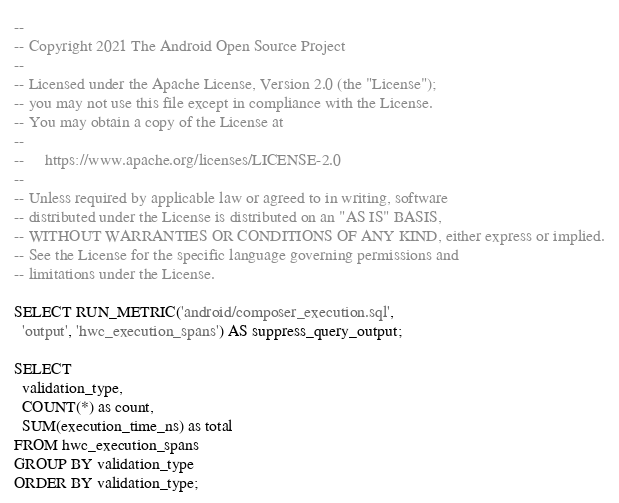<code> <loc_0><loc_0><loc_500><loc_500><_SQL_>--
-- Copyright 2021 The Android Open Source Project
--
-- Licensed under the Apache License, Version 2.0 (the "License");
-- you may not use this file except in compliance with the License.
-- You may obtain a copy of the License at
--
--     https://www.apache.org/licenses/LICENSE-2.0
--
-- Unless required by applicable law or agreed to in writing, software
-- distributed under the License is distributed on an "AS IS" BASIS,
-- WITHOUT WARRANTIES OR CONDITIONS OF ANY KIND, either express or implied.
-- See the License for the specific language governing permissions and
-- limitations under the License.

SELECT RUN_METRIC('android/composer_execution.sql',
  'output', 'hwc_execution_spans') AS suppress_query_output;

SELECT
  validation_type,
  COUNT(*) as count,
  SUM(execution_time_ns) as total
FROM hwc_execution_spans
GROUP BY validation_type
ORDER BY validation_type;
</code> 